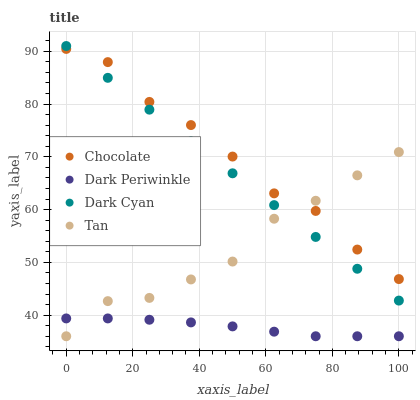Does Dark Periwinkle have the minimum area under the curve?
Answer yes or no. Yes. Does Chocolate have the maximum area under the curve?
Answer yes or no. Yes. Does Tan have the minimum area under the curve?
Answer yes or no. No. Does Tan have the maximum area under the curve?
Answer yes or no. No. Is Dark Cyan the smoothest?
Answer yes or no. Yes. Is Tan the roughest?
Answer yes or no. Yes. Is Dark Periwinkle the smoothest?
Answer yes or no. No. Is Dark Periwinkle the roughest?
Answer yes or no. No. Does Tan have the lowest value?
Answer yes or no. Yes. Does Chocolate have the lowest value?
Answer yes or no. No. Does Dark Cyan have the highest value?
Answer yes or no. Yes. Does Tan have the highest value?
Answer yes or no. No. Is Dark Periwinkle less than Chocolate?
Answer yes or no. Yes. Is Chocolate greater than Dark Periwinkle?
Answer yes or no. Yes. Does Chocolate intersect Dark Cyan?
Answer yes or no. Yes. Is Chocolate less than Dark Cyan?
Answer yes or no. No. Is Chocolate greater than Dark Cyan?
Answer yes or no. No. Does Dark Periwinkle intersect Chocolate?
Answer yes or no. No. 